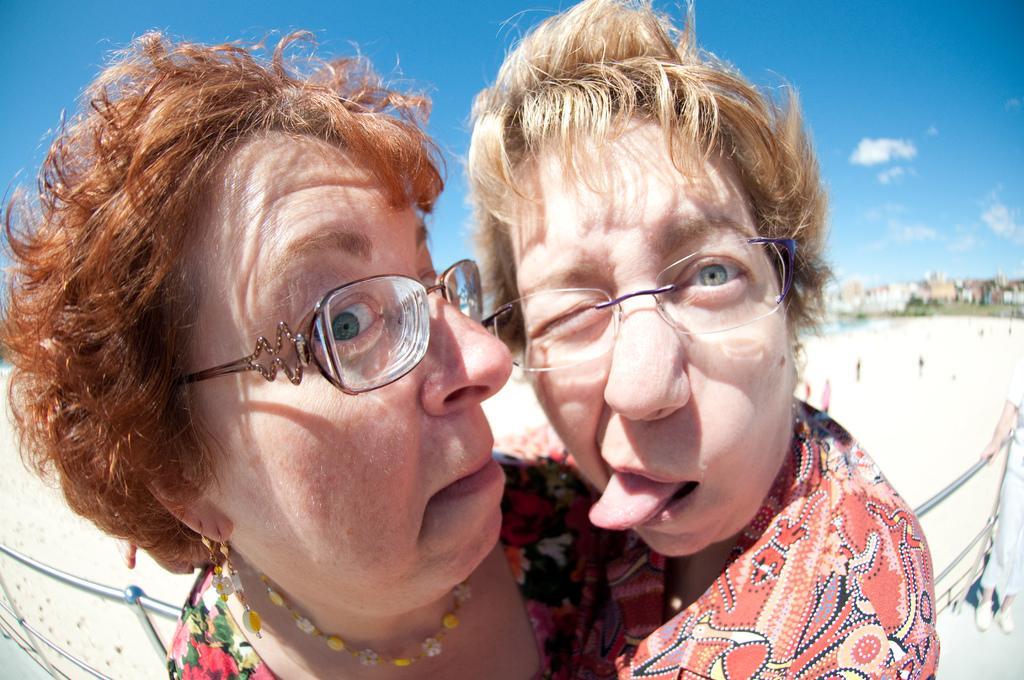Can you describe this image briefly? In this picture we can observe two women wearing spectacles. Both of them are wearing red color dresses. We can observe railing behind them. In the background there are buildings and sky with some clouds. 